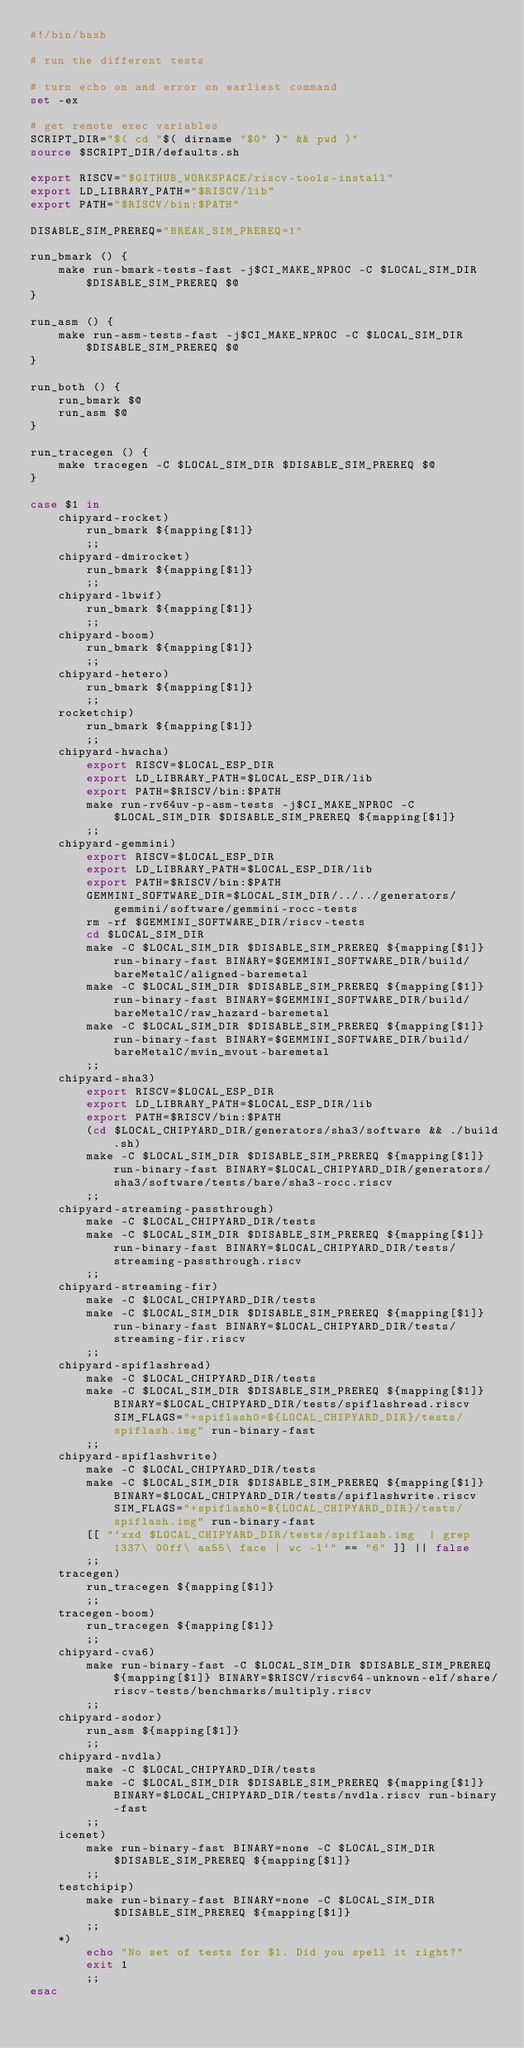Convert code to text. <code><loc_0><loc_0><loc_500><loc_500><_Bash_>#!/bin/bash

# run the different tests

# turn echo on and error on earliest command
set -ex

# get remote exec variables
SCRIPT_DIR="$( cd "$( dirname "$0" )" && pwd )"
source $SCRIPT_DIR/defaults.sh

export RISCV="$GITHUB_WORKSPACE/riscv-tools-install"
export LD_LIBRARY_PATH="$RISCV/lib"
export PATH="$RISCV/bin:$PATH"

DISABLE_SIM_PREREQ="BREAK_SIM_PREREQ=1"

run_bmark () {
    make run-bmark-tests-fast -j$CI_MAKE_NPROC -C $LOCAL_SIM_DIR $DISABLE_SIM_PREREQ $@
}

run_asm () {
    make run-asm-tests-fast -j$CI_MAKE_NPROC -C $LOCAL_SIM_DIR $DISABLE_SIM_PREREQ $@
}

run_both () {
    run_bmark $@
    run_asm $@
}

run_tracegen () {
    make tracegen -C $LOCAL_SIM_DIR $DISABLE_SIM_PREREQ $@
}

case $1 in
    chipyard-rocket)
        run_bmark ${mapping[$1]}
        ;;
    chipyard-dmirocket)
        run_bmark ${mapping[$1]}
        ;;
    chipyard-lbwif)
        run_bmark ${mapping[$1]}
        ;;
    chipyard-boom)
        run_bmark ${mapping[$1]}
        ;;
    chipyard-hetero)
        run_bmark ${mapping[$1]}
        ;;
    rocketchip)
        run_bmark ${mapping[$1]}
        ;;
    chipyard-hwacha)
        export RISCV=$LOCAL_ESP_DIR
        export LD_LIBRARY_PATH=$LOCAL_ESP_DIR/lib
        export PATH=$RISCV/bin:$PATH
        make run-rv64uv-p-asm-tests -j$CI_MAKE_NPROC -C $LOCAL_SIM_DIR $DISABLE_SIM_PREREQ ${mapping[$1]}
        ;;
    chipyard-gemmini)
        export RISCV=$LOCAL_ESP_DIR
        export LD_LIBRARY_PATH=$LOCAL_ESP_DIR/lib
        export PATH=$RISCV/bin:$PATH
        GEMMINI_SOFTWARE_DIR=$LOCAL_SIM_DIR/../../generators/gemmini/software/gemmini-rocc-tests
        rm -rf $GEMMINI_SOFTWARE_DIR/riscv-tests
        cd $LOCAL_SIM_DIR
        make -C $LOCAL_SIM_DIR $DISABLE_SIM_PREREQ ${mapping[$1]} run-binary-fast BINARY=$GEMMINI_SOFTWARE_DIR/build/bareMetalC/aligned-baremetal
        make -C $LOCAL_SIM_DIR $DISABLE_SIM_PREREQ ${mapping[$1]} run-binary-fast BINARY=$GEMMINI_SOFTWARE_DIR/build/bareMetalC/raw_hazard-baremetal
        make -C $LOCAL_SIM_DIR $DISABLE_SIM_PREREQ ${mapping[$1]} run-binary-fast BINARY=$GEMMINI_SOFTWARE_DIR/build/bareMetalC/mvin_mvout-baremetal
        ;;
    chipyard-sha3)
        export RISCV=$LOCAL_ESP_DIR
        export LD_LIBRARY_PATH=$LOCAL_ESP_DIR/lib
        export PATH=$RISCV/bin:$PATH
        (cd $LOCAL_CHIPYARD_DIR/generators/sha3/software && ./build.sh)
        make -C $LOCAL_SIM_DIR $DISABLE_SIM_PREREQ ${mapping[$1]} run-binary-fast BINARY=$LOCAL_CHIPYARD_DIR/generators/sha3/software/tests/bare/sha3-rocc.riscv
        ;;
    chipyard-streaming-passthrough)
        make -C $LOCAL_CHIPYARD_DIR/tests
        make -C $LOCAL_SIM_DIR $DISABLE_SIM_PREREQ ${mapping[$1]} run-binary-fast BINARY=$LOCAL_CHIPYARD_DIR/tests/streaming-passthrough.riscv
        ;;
    chipyard-streaming-fir)
        make -C $LOCAL_CHIPYARD_DIR/tests
        make -C $LOCAL_SIM_DIR $DISABLE_SIM_PREREQ ${mapping[$1]} run-binary-fast BINARY=$LOCAL_CHIPYARD_DIR/tests/streaming-fir.riscv
        ;;
    chipyard-spiflashread)
        make -C $LOCAL_CHIPYARD_DIR/tests
        make -C $LOCAL_SIM_DIR $DISABLE_SIM_PREREQ ${mapping[$1]} BINARY=$LOCAL_CHIPYARD_DIR/tests/spiflashread.riscv SIM_FLAGS="+spiflash0=${LOCAL_CHIPYARD_DIR}/tests/spiflash.img" run-binary-fast
        ;;
    chipyard-spiflashwrite)
        make -C $LOCAL_CHIPYARD_DIR/tests
        make -C $LOCAL_SIM_DIR $DISABLE_SIM_PREREQ ${mapping[$1]} BINARY=$LOCAL_CHIPYARD_DIR/tests/spiflashwrite.riscv SIM_FLAGS="+spiflash0=${LOCAL_CHIPYARD_DIR}/tests/spiflash.img" run-binary-fast
        [[ "`xxd $LOCAL_CHIPYARD_DIR/tests/spiflash.img  | grep 1337\ 00ff\ aa55\ face | wc -l`" == "6" ]] || false
        ;;
    tracegen)
        run_tracegen ${mapping[$1]}
        ;;
    tracegen-boom)
        run_tracegen ${mapping[$1]}
        ;;
    chipyard-cva6)
        make run-binary-fast -C $LOCAL_SIM_DIR $DISABLE_SIM_PREREQ ${mapping[$1]} BINARY=$RISCV/riscv64-unknown-elf/share/riscv-tests/benchmarks/multiply.riscv
        ;;
    chipyard-sodor)
        run_asm ${mapping[$1]}
        ;;
    chipyard-nvdla)
        make -C $LOCAL_CHIPYARD_DIR/tests
        make -C $LOCAL_SIM_DIR $DISABLE_SIM_PREREQ ${mapping[$1]} BINARY=$LOCAL_CHIPYARD_DIR/tests/nvdla.riscv run-binary-fast
        ;;
    icenet)
        make run-binary-fast BINARY=none -C $LOCAL_SIM_DIR $DISABLE_SIM_PREREQ ${mapping[$1]}
        ;;
    testchipip)
        make run-binary-fast BINARY=none -C $LOCAL_SIM_DIR $DISABLE_SIM_PREREQ ${mapping[$1]}
        ;;
    *)
        echo "No set of tests for $1. Did you spell it right?"
        exit 1
        ;;
esac
</code> 